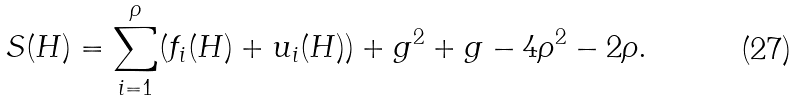<formula> <loc_0><loc_0><loc_500><loc_500>S ( H ) = \sum _ { i = 1 } ^ { \rho } ( f _ { i } ( H ) + u _ { i } ( H ) ) + g ^ { 2 } + g - 4 \rho ^ { 2 } - 2 \rho .</formula> 